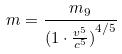<formula> <loc_0><loc_0><loc_500><loc_500>m = \frac { m _ { 9 } } { ( { 1 \cdot \frac { v ^ { 5 } } { c ^ { 5 } } ) } ^ { 4 / 5 } }</formula> 